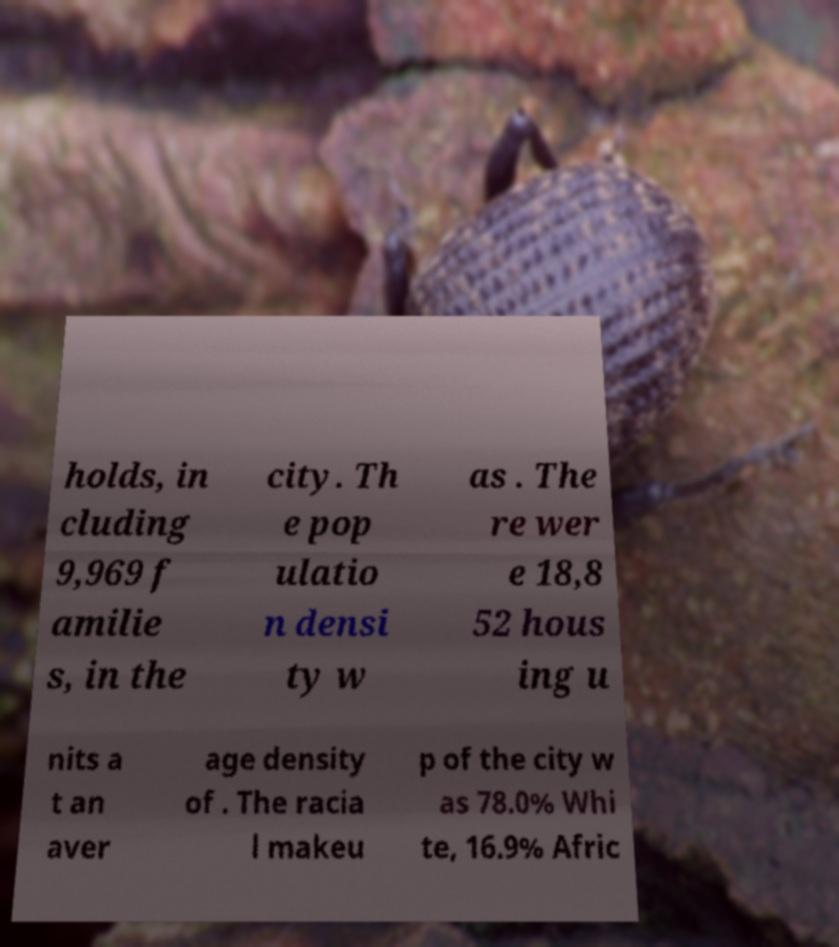Can you accurately transcribe the text from the provided image for me? holds, in cluding 9,969 f amilie s, in the city. Th e pop ulatio n densi ty w as . The re wer e 18,8 52 hous ing u nits a t an aver age density of . The racia l makeu p of the city w as 78.0% Whi te, 16.9% Afric 